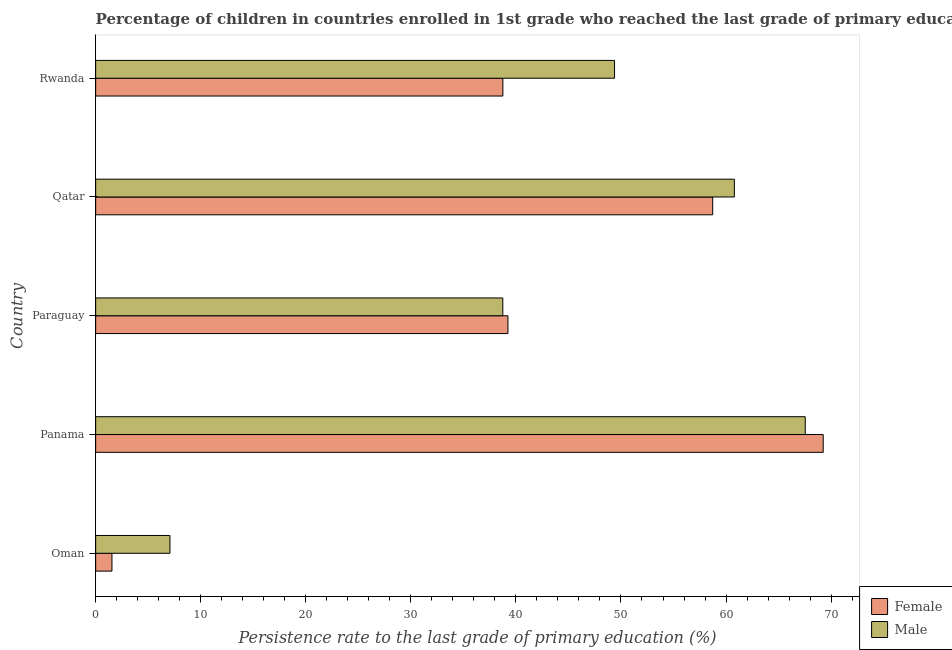Are the number of bars per tick equal to the number of legend labels?
Provide a succinct answer. Yes. How many bars are there on the 4th tick from the top?
Ensure brevity in your answer.  2. How many bars are there on the 3rd tick from the bottom?
Offer a terse response. 2. What is the label of the 1st group of bars from the top?
Give a very brief answer. Rwanda. In how many cases, is the number of bars for a given country not equal to the number of legend labels?
Make the answer very short. 0. What is the persistence rate of male students in Qatar?
Keep it short and to the point. 60.79. Across all countries, what is the maximum persistence rate of female students?
Give a very brief answer. 69.25. Across all countries, what is the minimum persistence rate of female students?
Make the answer very short. 1.55. In which country was the persistence rate of male students maximum?
Your response must be concise. Panama. In which country was the persistence rate of female students minimum?
Make the answer very short. Oman. What is the total persistence rate of male students in the graph?
Ensure brevity in your answer.  223.54. What is the difference between the persistence rate of male students in Paraguay and that in Qatar?
Keep it short and to the point. -22.04. What is the difference between the persistence rate of male students in Paraguay and the persistence rate of female students in Rwanda?
Offer a terse response. -0. What is the average persistence rate of male students per country?
Your answer should be very brief. 44.71. What is the difference between the persistence rate of male students and persistence rate of female students in Paraguay?
Keep it short and to the point. -0.49. In how many countries, is the persistence rate of female students greater than 54 %?
Give a very brief answer. 2. What is the ratio of the persistence rate of female students in Qatar to that in Rwanda?
Make the answer very short. 1.51. Is the difference between the persistence rate of female students in Oman and Qatar greater than the difference between the persistence rate of male students in Oman and Qatar?
Make the answer very short. No. What is the difference between the highest and the second highest persistence rate of female students?
Provide a short and direct response. 10.52. What is the difference between the highest and the lowest persistence rate of male students?
Provide a succinct answer. 60.47. What does the 1st bar from the bottom in Paraguay represents?
Make the answer very short. Female. Are all the bars in the graph horizontal?
Offer a very short reply. Yes. How many countries are there in the graph?
Keep it short and to the point. 5. What is the difference between two consecutive major ticks on the X-axis?
Ensure brevity in your answer.  10. Are the values on the major ticks of X-axis written in scientific E-notation?
Provide a short and direct response. No. Where does the legend appear in the graph?
Ensure brevity in your answer.  Bottom right. How many legend labels are there?
Provide a short and direct response. 2. What is the title of the graph?
Your answer should be compact. Percentage of children in countries enrolled in 1st grade who reached the last grade of primary education. Does "Largest city" appear as one of the legend labels in the graph?
Provide a succinct answer. No. What is the label or title of the X-axis?
Offer a very short reply. Persistence rate to the last grade of primary education (%). What is the label or title of the Y-axis?
Ensure brevity in your answer.  Country. What is the Persistence rate to the last grade of primary education (%) of Female in Oman?
Offer a very short reply. 1.55. What is the Persistence rate to the last grade of primary education (%) of Male in Oman?
Keep it short and to the point. 7.07. What is the Persistence rate to the last grade of primary education (%) in Female in Panama?
Keep it short and to the point. 69.25. What is the Persistence rate to the last grade of primary education (%) in Male in Panama?
Your answer should be very brief. 67.54. What is the Persistence rate to the last grade of primary education (%) in Female in Paraguay?
Give a very brief answer. 39.24. What is the Persistence rate to the last grade of primary education (%) in Male in Paraguay?
Provide a short and direct response. 38.75. What is the Persistence rate to the last grade of primary education (%) of Female in Qatar?
Your response must be concise. 58.73. What is the Persistence rate to the last grade of primary education (%) in Male in Qatar?
Ensure brevity in your answer.  60.79. What is the Persistence rate to the last grade of primary education (%) of Female in Rwanda?
Provide a short and direct response. 38.76. What is the Persistence rate to the last grade of primary education (%) in Male in Rwanda?
Make the answer very short. 49.39. Across all countries, what is the maximum Persistence rate to the last grade of primary education (%) of Female?
Give a very brief answer. 69.25. Across all countries, what is the maximum Persistence rate to the last grade of primary education (%) in Male?
Offer a very short reply. 67.54. Across all countries, what is the minimum Persistence rate to the last grade of primary education (%) of Female?
Provide a short and direct response. 1.55. Across all countries, what is the minimum Persistence rate to the last grade of primary education (%) in Male?
Make the answer very short. 7.07. What is the total Persistence rate to the last grade of primary education (%) in Female in the graph?
Your answer should be very brief. 207.53. What is the total Persistence rate to the last grade of primary education (%) of Male in the graph?
Your response must be concise. 223.54. What is the difference between the Persistence rate to the last grade of primary education (%) of Female in Oman and that in Panama?
Your answer should be compact. -67.7. What is the difference between the Persistence rate to the last grade of primary education (%) of Male in Oman and that in Panama?
Your answer should be very brief. -60.47. What is the difference between the Persistence rate to the last grade of primary education (%) of Female in Oman and that in Paraguay?
Make the answer very short. -37.69. What is the difference between the Persistence rate to the last grade of primary education (%) of Male in Oman and that in Paraguay?
Give a very brief answer. -31.68. What is the difference between the Persistence rate to the last grade of primary education (%) in Female in Oman and that in Qatar?
Offer a terse response. -57.18. What is the difference between the Persistence rate to the last grade of primary education (%) in Male in Oman and that in Qatar?
Provide a short and direct response. -53.72. What is the difference between the Persistence rate to the last grade of primary education (%) of Female in Oman and that in Rwanda?
Offer a terse response. -37.21. What is the difference between the Persistence rate to the last grade of primary education (%) of Male in Oman and that in Rwanda?
Offer a terse response. -42.32. What is the difference between the Persistence rate to the last grade of primary education (%) of Female in Panama and that in Paraguay?
Your answer should be compact. 30.01. What is the difference between the Persistence rate to the last grade of primary education (%) in Male in Panama and that in Paraguay?
Make the answer very short. 28.79. What is the difference between the Persistence rate to the last grade of primary education (%) in Female in Panama and that in Qatar?
Provide a succinct answer. 10.52. What is the difference between the Persistence rate to the last grade of primary education (%) of Male in Panama and that in Qatar?
Give a very brief answer. 6.75. What is the difference between the Persistence rate to the last grade of primary education (%) in Female in Panama and that in Rwanda?
Offer a terse response. 30.49. What is the difference between the Persistence rate to the last grade of primary education (%) of Male in Panama and that in Rwanda?
Keep it short and to the point. 18.15. What is the difference between the Persistence rate to the last grade of primary education (%) of Female in Paraguay and that in Qatar?
Ensure brevity in your answer.  -19.49. What is the difference between the Persistence rate to the last grade of primary education (%) of Male in Paraguay and that in Qatar?
Your response must be concise. -22.04. What is the difference between the Persistence rate to the last grade of primary education (%) in Female in Paraguay and that in Rwanda?
Your answer should be compact. 0.48. What is the difference between the Persistence rate to the last grade of primary education (%) of Male in Paraguay and that in Rwanda?
Provide a succinct answer. -10.63. What is the difference between the Persistence rate to the last grade of primary education (%) in Female in Qatar and that in Rwanda?
Provide a succinct answer. 19.97. What is the difference between the Persistence rate to the last grade of primary education (%) in Male in Qatar and that in Rwanda?
Provide a short and direct response. 11.4. What is the difference between the Persistence rate to the last grade of primary education (%) in Female in Oman and the Persistence rate to the last grade of primary education (%) in Male in Panama?
Give a very brief answer. -65.99. What is the difference between the Persistence rate to the last grade of primary education (%) in Female in Oman and the Persistence rate to the last grade of primary education (%) in Male in Paraguay?
Ensure brevity in your answer.  -37.2. What is the difference between the Persistence rate to the last grade of primary education (%) of Female in Oman and the Persistence rate to the last grade of primary education (%) of Male in Qatar?
Your answer should be compact. -59.24. What is the difference between the Persistence rate to the last grade of primary education (%) in Female in Oman and the Persistence rate to the last grade of primary education (%) in Male in Rwanda?
Give a very brief answer. -47.84. What is the difference between the Persistence rate to the last grade of primary education (%) of Female in Panama and the Persistence rate to the last grade of primary education (%) of Male in Paraguay?
Provide a short and direct response. 30.5. What is the difference between the Persistence rate to the last grade of primary education (%) in Female in Panama and the Persistence rate to the last grade of primary education (%) in Male in Qatar?
Your response must be concise. 8.46. What is the difference between the Persistence rate to the last grade of primary education (%) in Female in Panama and the Persistence rate to the last grade of primary education (%) in Male in Rwanda?
Offer a very short reply. 19.86. What is the difference between the Persistence rate to the last grade of primary education (%) in Female in Paraguay and the Persistence rate to the last grade of primary education (%) in Male in Qatar?
Ensure brevity in your answer.  -21.55. What is the difference between the Persistence rate to the last grade of primary education (%) in Female in Paraguay and the Persistence rate to the last grade of primary education (%) in Male in Rwanda?
Ensure brevity in your answer.  -10.15. What is the difference between the Persistence rate to the last grade of primary education (%) of Female in Qatar and the Persistence rate to the last grade of primary education (%) of Male in Rwanda?
Offer a very short reply. 9.34. What is the average Persistence rate to the last grade of primary education (%) of Female per country?
Your answer should be very brief. 41.51. What is the average Persistence rate to the last grade of primary education (%) in Male per country?
Your answer should be very brief. 44.71. What is the difference between the Persistence rate to the last grade of primary education (%) in Female and Persistence rate to the last grade of primary education (%) in Male in Oman?
Offer a very short reply. -5.52. What is the difference between the Persistence rate to the last grade of primary education (%) of Female and Persistence rate to the last grade of primary education (%) of Male in Panama?
Keep it short and to the point. 1.71. What is the difference between the Persistence rate to the last grade of primary education (%) in Female and Persistence rate to the last grade of primary education (%) in Male in Paraguay?
Give a very brief answer. 0.49. What is the difference between the Persistence rate to the last grade of primary education (%) of Female and Persistence rate to the last grade of primary education (%) of Male in Qatar?
Make the answer very short. -2.06. What is the difference between the Persistence rate to the last grade of primary education (%) in Female and Persistence rate to the last grade of primary education (%) in Male in Rwanda?
Provide a succinct answer. -10.63. What is the ratio of the Persistence rate to the last grade of primary education (%) of Female in Oman to that in Panama?
Keep it short and to the point. 0.02. What is the ratio of the Persistence rate to the last grade of primary education (%) in Male in Oman to that in Panama?
Give a very brief answer. 0.1. What is the ratio of the Persistence rate to the last grade of primary education (%) in Female in Oman to that in Paraguay?
Offer a very short reply. 0.04. What is the ratio of the Persistence rate to the last grade of primary education (%) of Male in Oman to that in Paraguay?
Offer a very short reply. 0.18. What is the ratio of the Persistence rate to the last grade of primary education (%) in Female in Oman to that in Qatar?
Offer a very short reply. 0.03. What is the ratio of the Persistence rate to the last grade of primary education (%) of Male in Oman to that in Qatar?
Your answer should be very brief. 0.12. What is the ratio of the Persistence rate to the last grade of primary education (%) in Female in Oman to that in Rwanda?
Offer a very short reply. 0.04. What is the ratio of the Persistence rate to the last grade of primary education (%) in Male in Oman to that in Rwanda?
Offer a terse response. 0.14. What is the ratio of the Persistence rate to the last grade of primary education (%) of Female in Panama to that in Paraguay?
Your response must be concise. 1.76. What is the ratio of the Persistence rate to the last grade of primary education (%) in Male in Panama to that in Paraguay?
Make the answer very short. 1.74. What is the ratio of the Persistence rate to the last grade of primary education (%) in Female in Panama to that in Qatar?
Keep it short and to the point. 1.18. What is the ratio of the Persistence rate to the last grade of primary education (%) in Male in Panama to that in Qatar?
Your answer should be very brief. 1.11. What is the ratio of the Persistence rate to the last grade of primary education (%) in Female in Panama to that in Rwanda?
Make the answer very short. 1.79. What is the ratio of the Persistence rate to the last grade of primary education (%) in Male in Panama to that in Rwanda?
Your answer should be very brief. 1.37. What is the ratio of the Persistence rate to the last grade of primary education (%) in Female in Paraguay to that in Qatar?
Your answer should be compact. 0.67. What is the ratio of the Persistence rate to the last grade of primary education (%) in Male in Paraguay to that in Qatar?
Provide a short and direct response. 0.64. What is the ratio of the Persistence rate to the last grade of primary education (%) in Female in Paraguay to that in Rwanda?
Offer a very short reply. 1.01. What is the ratio of the Persistence rate to the last grade of primary education (%) of Male in Paraguay to that in Rwanda?
Provide a succinct answer. 0.78. What is the ratio of the Persistence rate to the last grade of primary education (%) of Female in Qatar to that in Rwanda?
Give a very brief answer. 1.52. What is the ratio of the Persistence rate to the last grade of primary education (%) of Male in Qatar to that in Rwanda?
Make the answer very short. 1.23. What is the difference between the highest and the second highest Persistence rate to the last grade of primary education (%) in Female?
Provide a succinct answer. 10.52. What is the difference between the highest and the second highest Persistence rate to the last grade of primary education (%) in Male?
Provide a succinct answer. 6.75. What is the difference between the highest and the lowest Persistence rate to the last grade of primary education (%) in Female?
Provide a short and direct response. 67.7. What is the difference between the highest and the lowest Persistence rate to the last grade of primary education (%) in Male?
Provide a succinct answer. 60.47. 